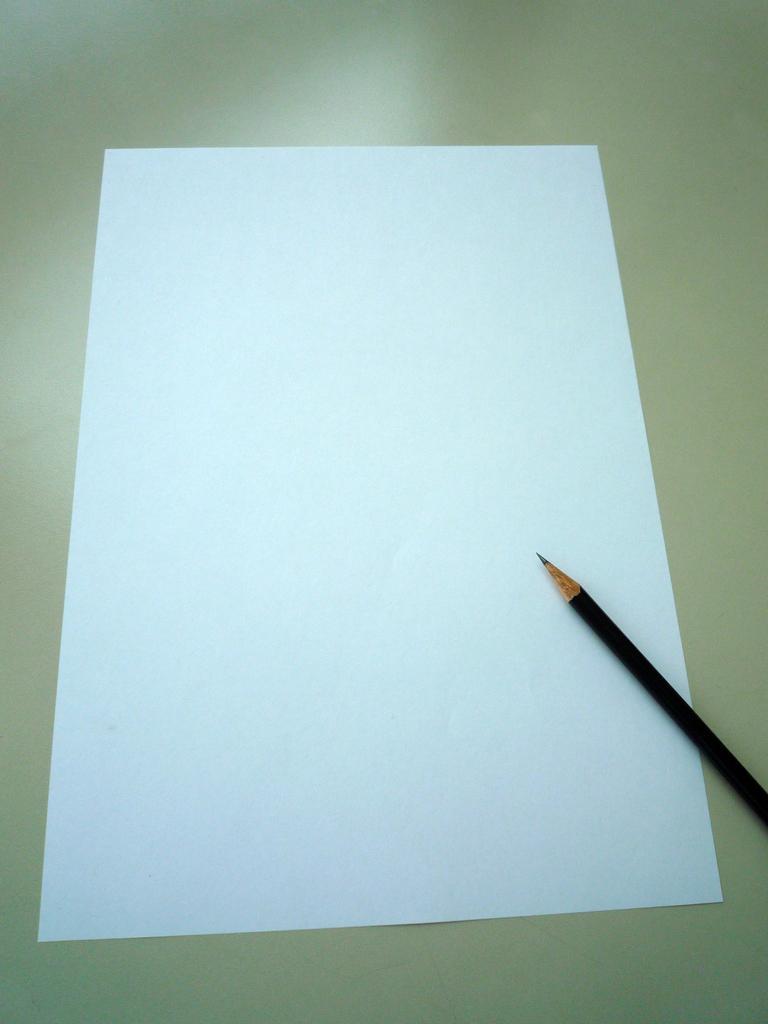In one or two sentences, can you explain what this image depicts? We can see a pencil on a white paper. 